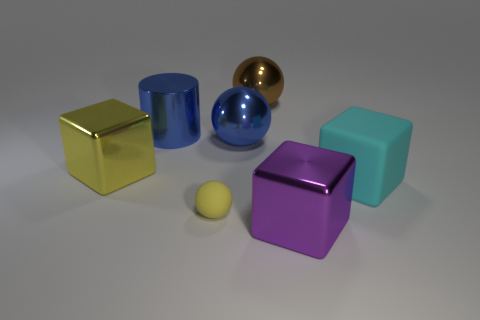Subtract 1 cubes. How many cubes are left? 2 Add 2 large blue shiny balls. How many objects exist? 9 Subtract all cubes. How many objects are left? 4 Add 3 large yellow blocks. How many large yellow blocks exist? 4 Subtract 0 red blocks. How many objects are left? 7 Subtract all big purple rubber cylinders. Subtract all big purple cubes. How many objects are left? 6 Add 4 small balls. How many small balls are left? 5 